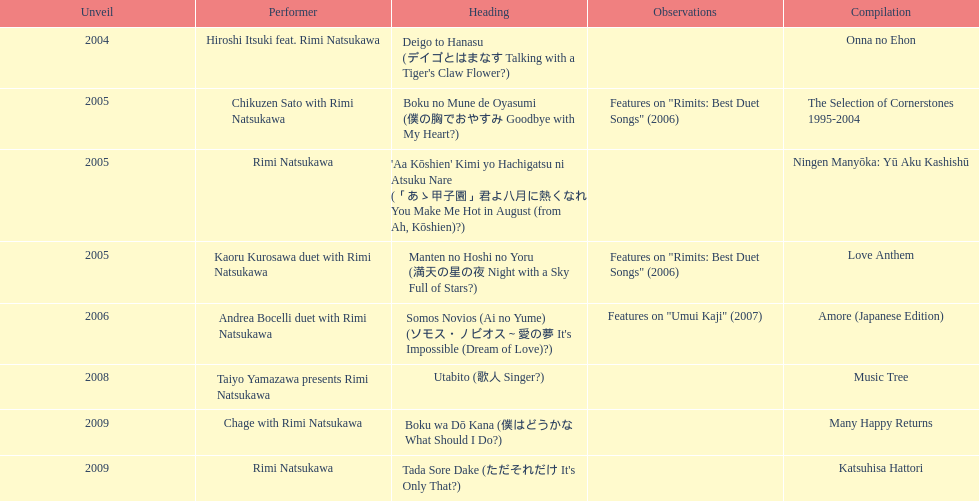What was the album released immediately before the one that had boku wa do kana on it? Music Tree. 